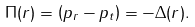Convert formula to latex. <formula><loc_0><loc_0><loc_500><loc_500>\Pi ( r ) = \left ( p _ { r } - p _ { t } \right ) = - \Delta ( r ) .</formula> 